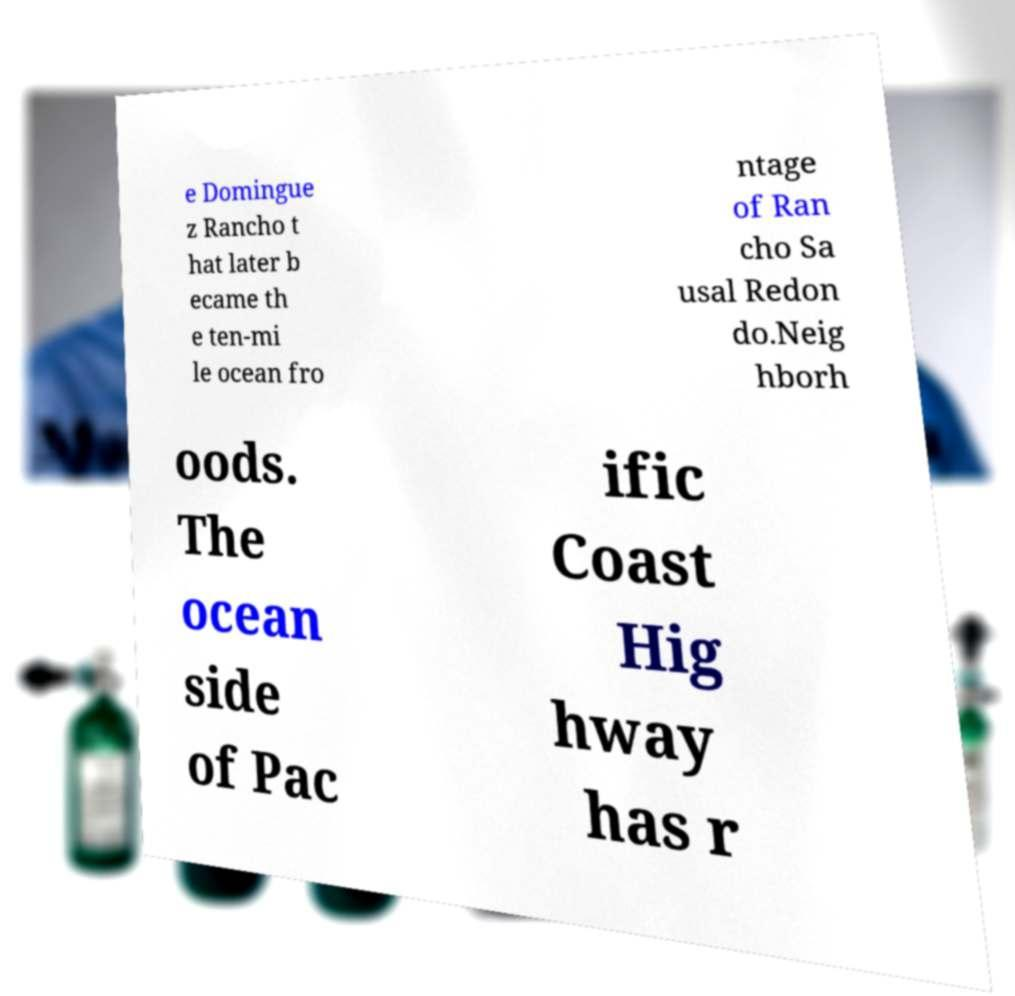What messages or text are displayed in this image? I need them in a readable, typed format. e Domingue z Rancho t hat later b ecame th e ten-mi le ocean fro ntage of Ran cho Sa usal Redon do.Neig hborh oods. The ocean side of Pac ific Coast Hig hway has r 